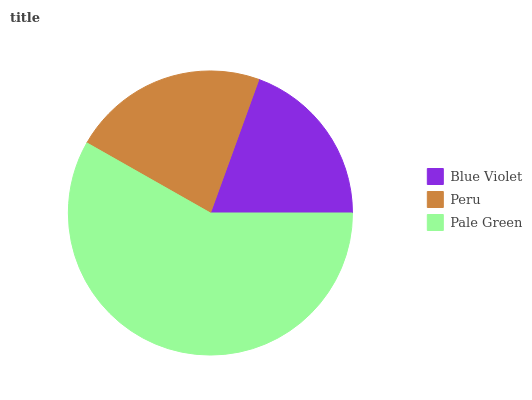Is Blue Violet the minimum?
Answer yes or no. Yes. Is Pale Green the maximum?
Answer yes or no. Yes. Is Peru the minimum?
Answer yes or no. No. Is Peru the maximum?
Answer yes or no. No. Is Peru greater than Blue Violet?
Answer yes or no. Yes. Is Blue Violet less than Peru?
Answer yes or no. Yes. Is Blue Violet greater than Peru?
Answer yes or no. No. Is Peru less than Blue Violet?
Answer yes or no. No. Is Peru the high median?
Answer yes or no. Yes. Is Peru the low median?
Answer yes or no. Yes. Is Pale Green the high median?
Answer yes or no. No. Is Pale Green the low median?
Answer yes or no. No. 